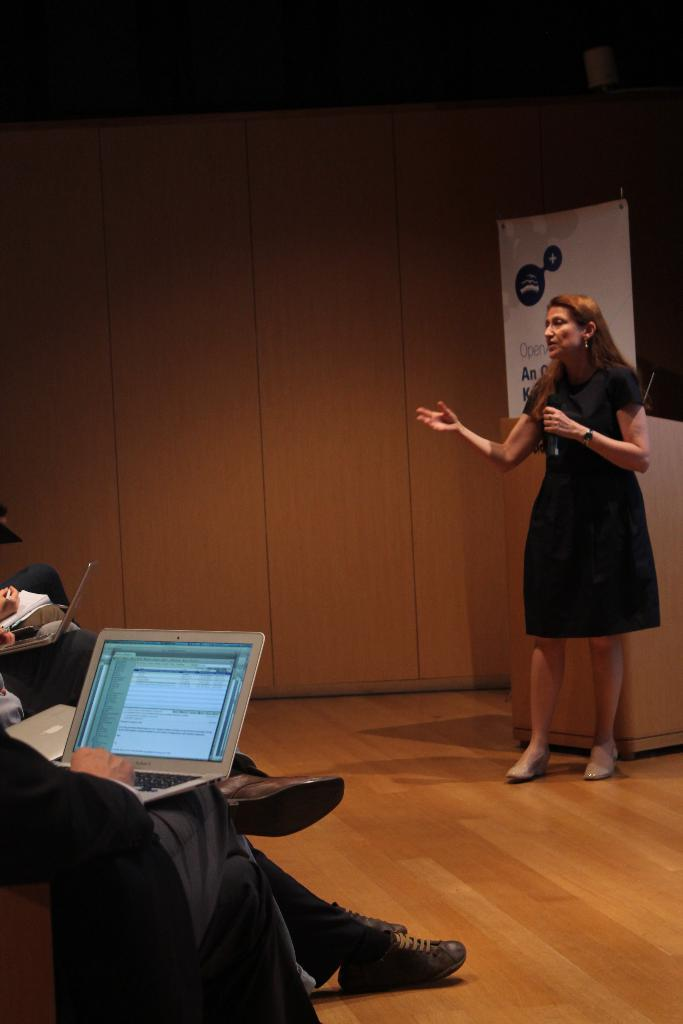What are the people in the image doing? There is a group of people sitting in the image, which suggests they might be attending an event or gathering. What objects can be seen in the image related to technology? There are laptops visible in the image. What is the woman in the image doing? The woman is standing in the image and holding a microphone, which suggests she might be speaking or presenting. What is the woman standing near in the image? There is a podium in the image, which is often used by speakers during presentations or speeches. What is on the wall in the image? There is a board in the image, which could be used for displaying information or notes. How many passengers are visible in the image? There is no reference to passengers in the image; it features a group of people sitting, a woman standing with a microphone, laptops, a podium, a board, and a wall. What type of property is being played in the image? There is no property or game being played in the image; it depicts a group of people sitting, a woman standing with a microphone, laptops, a podium, a board, and a wall. 